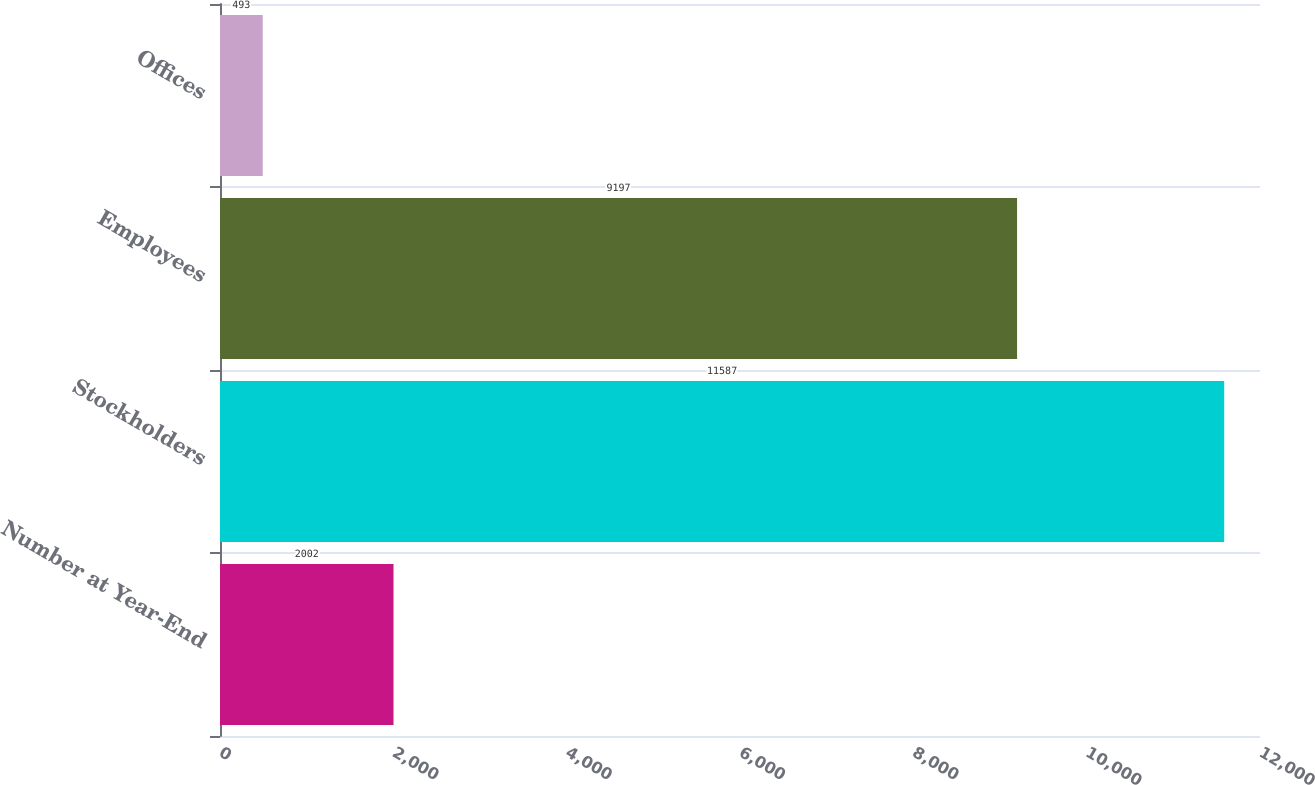Convert chart. <chart><loc_0><loc_0><loc_500><loc_500><bar_chart><fcel>Number at Year-End<fcel>Stockholders<fcel>Employees<fcel>Offices<nl><fcel>2002<fcel>11587<fcel>9197<fcel>493<nl></chart> 